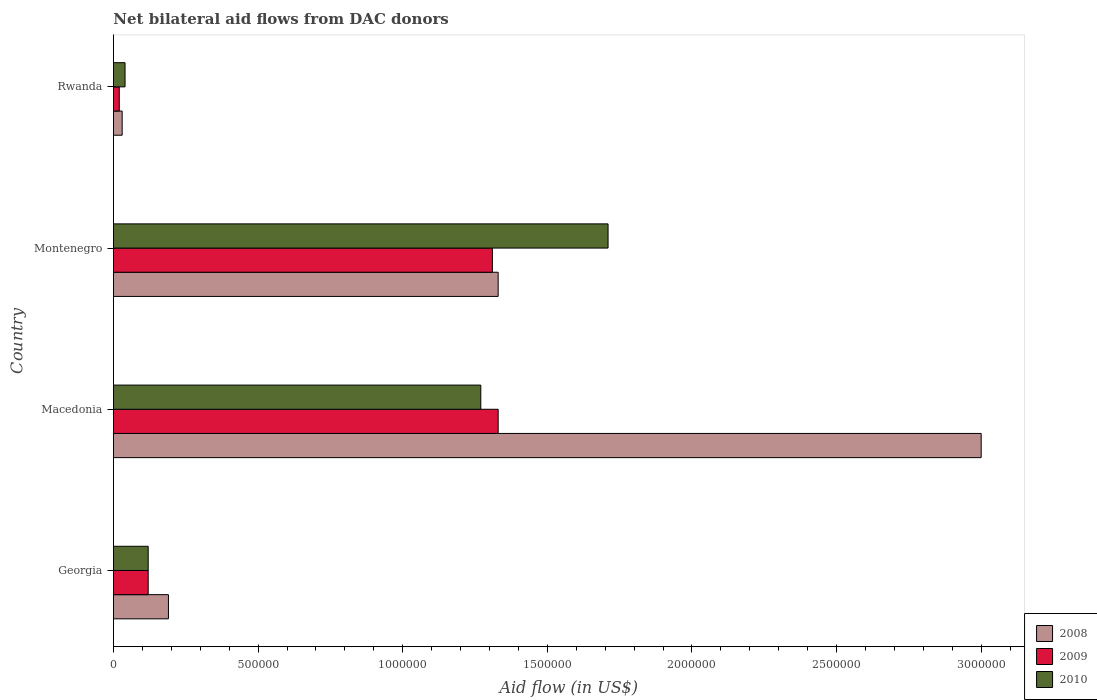Are the number of bars on each tick of the Y-axis equal?
Give a very brief answer. Yes. How many bars are there on the 2nd tick from the top?
Your answer should be compact. 3. How many bars are there on the 4th tick from the bottom?
Your response must be concise. 3. What is the label of the 2nd group of bars from the top?
Your response must be concise. Montenegro. What is the net bilateral aid flow in 2009 in Montenegro?
Your response must be concise. 1.31e+06. Across all countries, what is the maximum net bilateral aid flow in 2010?
Make the answer very short. 1.71e+06. Across all countries, what is the minimum net bilateral aid flow in 2010?
Give a very brief answer. 4.00e+04. In which country was the net bilateral aid flow in 2010 maximum?
Offer a terse response. Montenegro. In which country was the net bilateral aid flow in 2010 minimum?
Your answer should be very brief. Rwanda. What is the total net bilateral aid flow in 2009 in the graph?
Keep it short and to the point. 2.78e+06. What is the difference between the net bilateral aid flow in 2009 in Macedonia and that in Montenegro?
Your response must be concise. 2.00e+04. What is the difference between the net bilateral aid flow in 2008 in Rwanda and the net bilateral aid flow in 2010 in Montenegro?
Provide a succinct answer. -1.68e+06. What is the average net bilateral aid flow in 2008 per country?
Provide a succinct answer. 1.14e+06. What is the difference between the net bilateral aid flow in 2008 and net bilateral aid flow in 2010 in Macedonia?
Your response must be concise. 1.73e+06. What is the ratio of the net bilateral aid flow in 2009 in Macedonia to that in Rwanda?
Your answer should be very brief. 66.5. Is the net bilateral aid flow in 2009 in Georgia less than that in Rwanda?
Offer a very short reply. No. Is the difference between the net bilateral aid flow in 2008 in Georgia and Montenegro greater than the difference between the net bilateral aid flow in 2010 in Georgia and Montenegro?
Ensure brevity in your answer.  Yes. What is the difference between the highest and the second highest net bilateral aid flow in 2008?
Make the answer very short. 1.67e+06. What is the difference between the highest and the lowest net bilateral aid flow in 2009?
Provide a succinct answer. 1.31e+06. What does the 3rd bar from the top in Georgia represents?
Ensure brevity in your answer.  2008. Are all the bars in the graph horizontal?
Provide a succinct answer. Yes. What is the difference between two consecutive major ticks on the X-axis?
Offer a terse response. 5.00e+05. Does the graph contain any zero values?
Offer a very short reply. No. Does the graph contain grids?
Offer a terse response. No. Where does the legend appear in the graph?
Make the answer very short. Bottom right. How are the legend labels stacked?
Offer a terse response. Vertical. What is the title of the graph?
Ensure brevity in your answer.  Net bilateral aid flows from DAC donors. What is the label or title of the X-axis?
Provide a short and direct response. Aid flow (in US$). What is the Aid flow (in US$) in 2008 in Georgia?
Ensure brevity in your answer.  1.90e+05. What is the Aid flow (in US$) in 2009 in Georgia?
Offer a very short reply. 1.20e+05. What is the Aid flow (in US$) in 2009 in Macedonia?
Your response must be concise. 1.33e+06. What is the Aid flow (in US$) of 2010 in Macedonia?
Offer a very short reply. 1.27e+06. What is the Aid flow (in US$) of 2008 in Montenegro?
Give a very brief answer. 1.33e+06. What is the Aid flow (in US$) of 2009 in Montenegro?
Keep it short and to the point. 1.31e+06. What is the Aid flow (in US$) in 2010 in Montenegro?
Your answer should be compact. 1.71e+06. What is the Aid flow (in US$) in 2010 in Rwanda?
Give a very brief answer. 4.00e+04. Across all countries, what is the maximum Aid flow (in US$) of 2009?
Your answer should be compact. 1.33e+06. Across all countries, what is the maximum Aid flow (in US$) of 2010?
Your response must be concise. 1.71e+06. Across all countries, what is the minimum Aid flow (in US$) in 2008?
Offer a very short reply. 3.00e+04. What is the total Aid flow (in US$) in 2008 in the graph?
Offer a very short reply. 4.55e+06. What is the total Aid flow (in US$) in 2009 in the graph?
Offer a very short reply. 2.78e+06. What is the total Aid flow (in US$) of 2010 in the graph?
Your response must be concise. 3.14e+06. What is the difference between the Aid flow (in US$) of 2008 in Georgia and that in Macedonia?
Ensure brevity in your answer.  -2.81e+06. What is the difference between the Aid flow (in US$) in 2009 in Georgia and that in Macedonia?
Your response must be concise. -1.21e+06. What is the difference between the Aid flow (in US$) of 2010 in Georgia and that in Macedonia?
Provide a succinct answer. -1.15e+06. What is the difference between the Aid flow (in US$) in 2008 in Georgia and that in Montenegro?
Provide a succinct answer. -1.14e+06. What is the difference between the Aid flow (in US$) in 2009 in Georgia and that in Montenegro?
Make the answer very short. -1.19e+06. What is the difference between the Aid flow (in US$) of 2010 in Georgia and that in Montenegro?
Ensure brevity in your answer.  -1.59e+06. What is the difference between the Aid flow (in US$) of 2009 in Georgia and that in Rwanda?
Your answer should be very brief. 1.00e+05. What is the difference between the Aid flow (in US$) of 2010 in Georgia and that in Rwanda?
Keep it short and to the point. 8.00e+04. What is the difference between the Aid flow (in US$) in 2008 in Macedonia and that in Montenegro?
Offer a very short reply. 1.67e+06. What is the difference between the Aid flow (in US$) of 2009 in Macedonia and that in Montenegro?
Give a very brief answer. 2.00e+04. What is the difference between the Aid flow (in US$) in 2010 in Macedonia and that in Montenegro?
Give a very brief answer. -4.40e+05. What is the difference between the Aid flow (in US$) in 2008 in Macedonia and that in Rwanda?
Provide a succinct answer. 2.97e+06. What is the difference between the Aid flow (in US$) in 2009 in Macedonia and that in Rwanda?
Offer a terse response. 1.31e+06. What is the difference between the Aid flow (in US$) of 2010 in Macedonia and that in Rwanda?
Keep it short and to the point. 1.23e+06. What is the difference between the Aid flow (in US$) of 2008 in Montenegro and that in Rwanda?
Ensure brevity in your answer.  1.30e+06. What is the difference between the Aid flow (in US$) of 2009 in Montenegro and that in Rwanda?
Give a very brief answer. 1.29e+06. What is the difference between the Aid flow (in US$) in 2010 in Montenegro and that in Rwanda?
Provide a succinct answer. 1.67e+06. What is the difference between the Aid flow (in US$) of 2008 in Georgia and the Aid flow (in US$) of 2009 in Macedonia?
Give a very brief answer. -1.14e+06. What is the difference between the Aid flow (in US$) of 2008 in Georgia and the Aid flow (in US$) of 2010 in Macedonia?
Provide a short and direct response. -1.08e+06. What is the difference between the Aid flow (in US$) of 2009 in Georgia and the Aid flow (in US$) of 2010 in Macedonia?
Offer a terse response. -1.15e+06. What is the difference between the Aid flow (in US$) in 2008 in Georgia and the Aid flow (in US$) in 2009 in Montenegro?
Your answer should be very brief. -1.12e+06. What is the difference between the Aid flow (in US$) of 2008 in Georgia and the Aid flow (in US$) of 2010 in Montenegro?
Provide a succinct answer. -1.52e+06. What is the difference between the Aid flow (in US$) in 2009 in Georgia and the Aid flow (in US$) in 2010 in Montenegro?
Ensure brevity in your answer.  -1.59e+06. What is the difference between the Aid flow (in US$) in 2008 in Georgia and the Aid flow (in US$) in 2009 in Rwanda?
Your answer should be very brief. 1.70e+05. What is the difference between the Aid flow (in US$) in 2008 in Georgia and the Aid flow (in US$) in 2010 in Rwanda?
Your response must be concise. 1.50e+05. What is the difference between the Aid flow (in US$) of 2008 in Macedonia and the Aid flow (in US$) of 2009 in Montenegro?
Your answer should be very brief. 1.69e+06. What is the difference between the Aid flow (in US$) in 2008 in Macedonia and the Aid flow (in US$) in 2010 in Montenegro?
Your response must be concise. 1.29e+06. What is the difference between the Aid flow (in US$) in 2009 in Macedonia and the Aid flow (in US$) in 2010 in Montenegro?
Provide a succinct answer. -3.80e+05. What is the difference between the Aid flow (in US$) in 2008 in Macedonia and the Aid flow (in US$) in 2009 in Rwanda?
Offer a terse response. 2.98e+06. What is the difference between the Aid flow (in US$) in 2008 in Macedonia and the Aid flow (in US$) in 2010 in Rwanda?
Give a very brief answer. 2.96e+06. What is the difference between the Aid flow (in US$) of 2009 in Macedonia and the Aid flow (in US$) of 2010 in Rwanda?
Provide a short and direct response. 1.29e+06. What is the difference between the Aid flow (in US$) in 2008 in Montenegro and the Aid flow (in US$) in 2009 in Rwanda?
Provide a short and direct response. 1.31e+06. What is the difference between the Aid flow (in US$) in 2008 in Montenegro and the Aid flow (in US$) in 2010 in Rwanda?
Your answer should be compact. 1.29e+06. What is the difference between the Aid flow (in US$) in 2009 in Montenegro and the Aid flow (in US$) in 2010 in Rwanda?
Make the answer very short. 1.27e+06. What is the average Aid flow (in US$) of 2008 per country?
Provide a short and direct response. 1.14e+06. What is the average Aid flow (in US$) of 2009 per country?
Make the answer very short. 6.95e+05. What is the average Aid flow (in US$) of 2010 per country?
Give a very brief answer. 7.85e+05. What is the difference between the Aid flow (in US$) of 2008 and Aid flow (in US$) of 2010 in Georgia?
Provide a short and direct response. 7.00e+04. What is the difference between the Aid flow (in US$) in 2008 and Aid flow (in US$) in 2009 in Macedonia?
Provide a short and direct response. 1.67e+06. What is the difference between the Aid flow (in US$) of 2008 and Aid flow (in US$) of 2010 in Macedonia?
Provide a succinct answer. 1.73e+06. What is the difference between the Aid flow (in US$) in 2008 and Aid flow (in US$) in 2009 in Montenegro?
Make the answer very short. 2.00e+04. What is the difference between the Aid flow (in US$) in 2008 and Aid flow (in US$) in 2010 in Montenegro?
Provide a short and direct response. -3.80e+05. What is the difference between the Aid flow (in US$) in 2009 and Aid flow (in US$) in 2010 in Montenegro?
Make the answer very short. -4.00e+05. What is the difference between the Aid flow (in US$) of 2008 and Aid flow (in US$) of 2010 in Rwanda?
Keep it short and to the point. -10000. What is the ratio of the Aid flow (in US$) in 2008 in Georgia to that in Macedonia?
Offer a very short reply. 0.06. What is the ratio of the Aid flow (in US$) of 2009 in Georgia to that in Macedonia?
Your response must be concise. 0.09. What is the ratio of the Aid flow (in US$) in 2010 in Georgia to that in Macedonia?
Provide a succinct answer. 0.09. What is the ratio of the Aid flow (in US$) of 2008 in Georgia to that in Montenegro?
Provide a short and direct response. 0.14. What is the ratio of the Aid flow (in US$) of 2009 in Georgia to that in Montenegro?
Offer a very short reply. 0.09. What is the ratio of the Aid flow (in US$) in 2010 in Georgia to that in Montenegro?
Ensure brevity in your answer.  0.07. What is the ratio of the Aid flow (in US$) of 2008 in Georgia to that in Rwanda?
Your answer should be compact. 6.33. What is the ratio of the Aid flow (in US$) of 2009 in Georgia to that in Rwanda?
Ensure brevity in your answer.  6. What is the ratio of the Aid flow (in US$) in 2010 in Georgia to that in Rwanda?
Your answer should be compact. 3. What is the ratio of the Aid flow (in US$) of 2008 in Macedonia to that in Montenegro?
Offer a very short reply. 2.26. What is the ratio of the Aid flow (in US$) of 2009 in Macedonia to that in Montenegro?
Your answer should be compact. 1.02. What is the ratio of the Aid flow (in US$) in 2010 in Macedonia to that in Montenegro?
Give a very brief answer. 0.74. What is the ratio of the Aid flow (in US$) of 2008 in Macedonia to that in Rwanda?
Your response must be concise. 100. What is the ratio of the Aid flow (in US$) of 2009 in Macedonia to that in Rwanda?
Your answer should be very brief. 66.5. What is the ratio of the Aid flow (in US$) of 2010 in Macedonia to that in Rwanda?
Offer a terse response. 31.75. What is the ratio of the Aid flow (in US$) in 2008 in Montenegro to that in Rwanda?
Your answer should be compact. 44.33. What is the ratio of the Aid flow (in US$) in 2009 in Montenegro to that in Rwanda?
Give a very brief answer. 65.5. What is the ratio of the Aid flow (in US$) of 2010 in Montenegro to that in Rwanda?
Provide a succinct answer. 42.75. What is the difference between the highest and the second highest Aid flow (in US$) of 2008?
Ensure brevity in your answer.  1.67e+06. What is the difference between the highest and the lowest Aid flow (in US$) of 2008?
Provide a succinct answer. 2.97e+06. What is the difference between the highest and the lowest Aid flow (in US$) in 2009?
Keep it short and to the point. 1.31e+06. What is the difference between the highest and the lowest Aid flow (in US$) of 2010?
Offer a very short reply. 1.67e+06. 